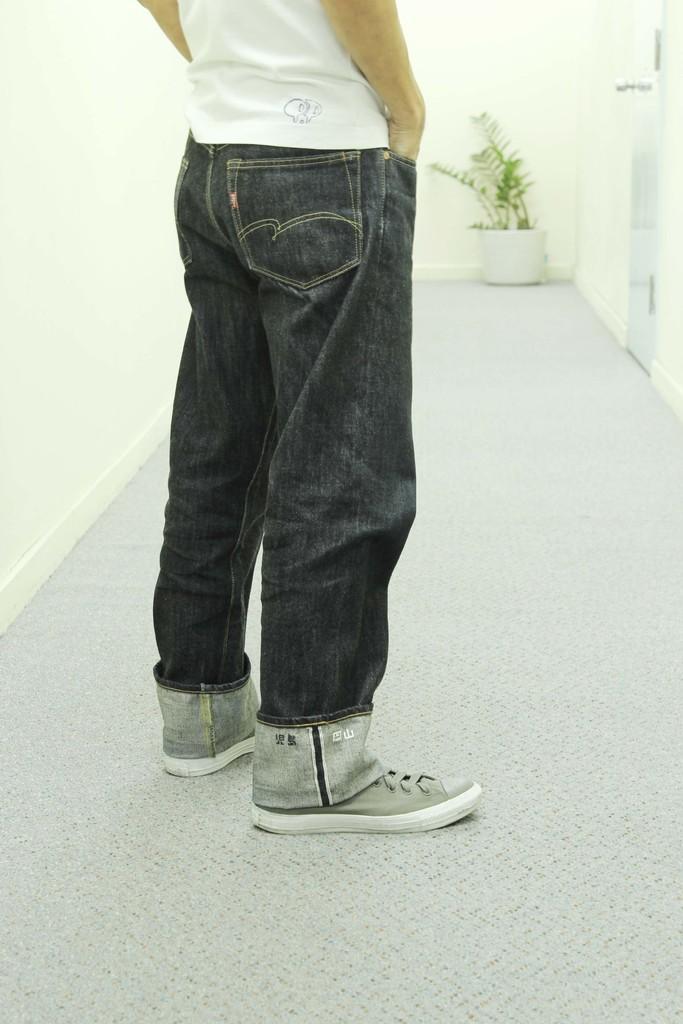Could you give a brief overview of what you see in this image? In this image we can see a person. There is a house plant in the image. There is a white color wall in the image. 